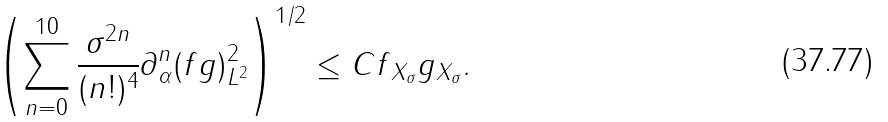Convert formula to latex. <formula><loc_0><loc_0><loc_500><loc_500>\left ( \sum _ { n = 0 } ^ { 1 0 } \frac { \sigma ^ { 2 n } } { ( n ! ) ^ { 4 } } \| \partial _ { \alpha } ^ { n } ( f g ) \| _ { L ^ { 2 } } ^ { 2 } \right ) ^ { 1 / 2 } \leq C \| f \| _ { X _ { \sigma } } \| g \| _ { X _ { \sigma } } .</formula> 